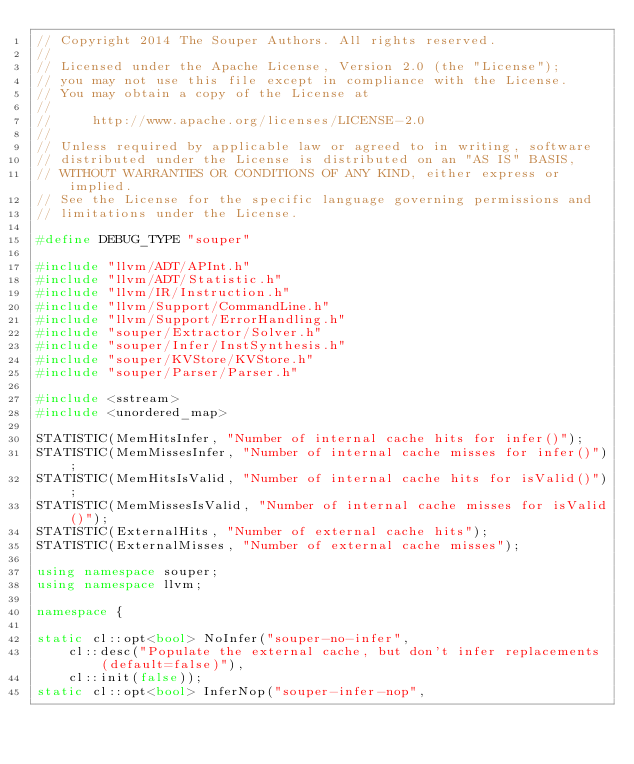<code> <loc_0><loc_0><loc_500><loc_500><_C++_>// Copyright 2014 The Souper Authors. All rights reserved.
//
// Licensed under the Apache License, Version 2.0 (the "License");
// you may not use this file except in compliance with the License.
// You may obtain a copy of the License at
//
//     http://www.apache.org/licenses/LICENSE-2.0
//
// Unless required by applicable law or agreed to in writing, software
// distributed under the License is distributed on an "AS IS" BASIS,
// WITHOUT WARRANTIES OR CONDITIONS OF ANY KIND, either express or implied.
// See the License for the specific language governing permissions and
// limitations under the License.

#define DEBUG_TYPE "souper"

#include "llvm/ADT/APInt.h"
#include "llvm/ADT/Statistic.h"
#include "llvm/IR/Instruction.h"
#include "llvm/Support/CommandLine.h"
#include "llvm/Support/ErrorHandling.h"
#include "souper/Extractor/Solver.h"
#include "souper/Infer/InstSynthesis.h"
#include "souper/KVStore/KVStore.h"
#include "souper/Parser/Parser.h"

#include <sstream>
#include <unordered_map>

STATISTIC(MemHitsInfer, "Number of internal cache hits for infer()");
STATISTIC(MemMissesInfer, "Number of internal cache misses for infer()");
STATISTIC(MemHitsIsValid, "Number of internal cache hits for isValid()");
STATISTIC(MemMissesIsValid, "Number of internal cache misses for isValid()");
STATISTIC(ExternalHits, "Number of external cache hits");
STATISTIC(ExternalMisses, "Number of external cache misses");

using namespace souper;
using namespace llvm;

namespace {

static cl::opt<bool> NoInfer("souper-no-infer",
    cl::desc("Populate the external cache, but don't infer replacements (default=false)"),
    cl::init(false));
static cl::opt<bool> InferNop("souper-infer-nop",</code> 